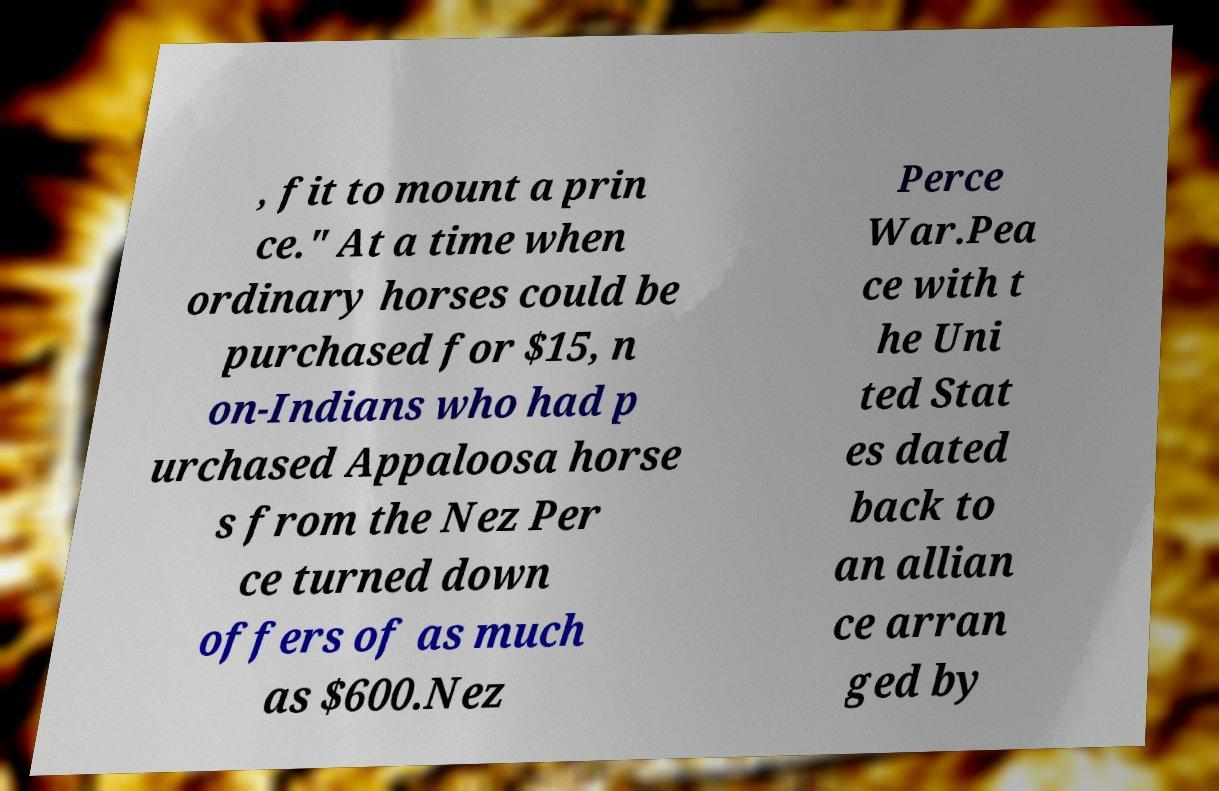Could you assist in decoding the text presented in this image and type it out clearly? , fit to mount a prin ce." At a time when ordinary horses could be purchased for $15, n on-Indians who had p urchased Appaloosa horse s from the Nez Per ce turned down offers of as much as $600.Nez Perce War.Pea ce with t he Uni ted Stat es dated back to an allian ce arran ged by 